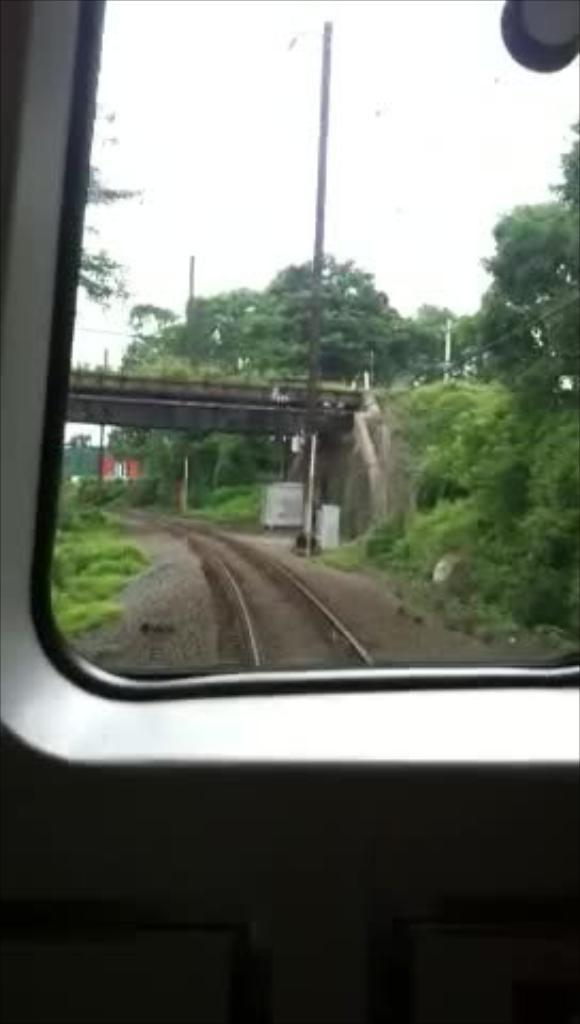What is the vantage point of the image? The image is taken from a train window. What type of vegetation can be seen in the image? There are trees visible in the image. What structure is present in the image? It appears to be a bridge in the image. What is the primary mode of transportation in the image? A railway track is present in the image. What is visible in the background of the image? The sky is visible in the background of the image. What type of flesh can be seen hanging from the bridge in the image? There is no flesh present in the image; it features a bridge and trees. What type of wood is used to construct the bridge in the image? The image does not provide enough detail to determine the type of wood used in the construction of the bridge. 